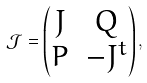<formula> <loc_0><loc_0><loc_500><loc_500>\mathcal { J } = \left ( \begin{matrix} J & Q \\ P & - J ^ { t } \end{matrix} \right ) ,</formula> 